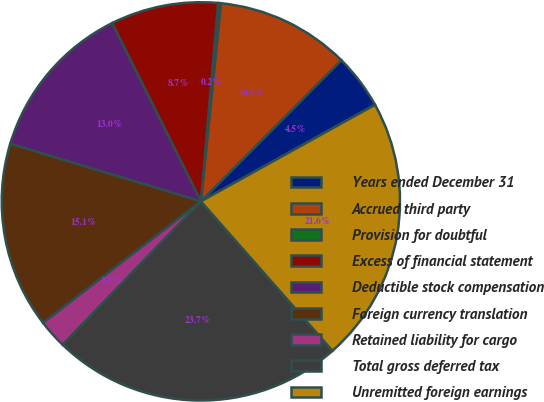Convert chart. <chart><loc_0><loc_0><loc_500><loc_500><pie_chart><fcel>Years ended December 31<fcel>Accrued third party<fcel>Provision for doubtful<fcel>Excess of financial statement<fcel>Deductible stock compensation<fcel>Foreign currency translation<fcel>Retained liability for cargo<fcel>Total gross deferred tax<fcel>Unremitted foreign earnings<nl><fcel>4.48%<fcel>10.86%<fcel>0.22%<fcel>8.73%<fcel>12.98%<fcel>15.11%<fcel>2.35%<fcel>23.7%<fcel>21.57%<nl></chart> 